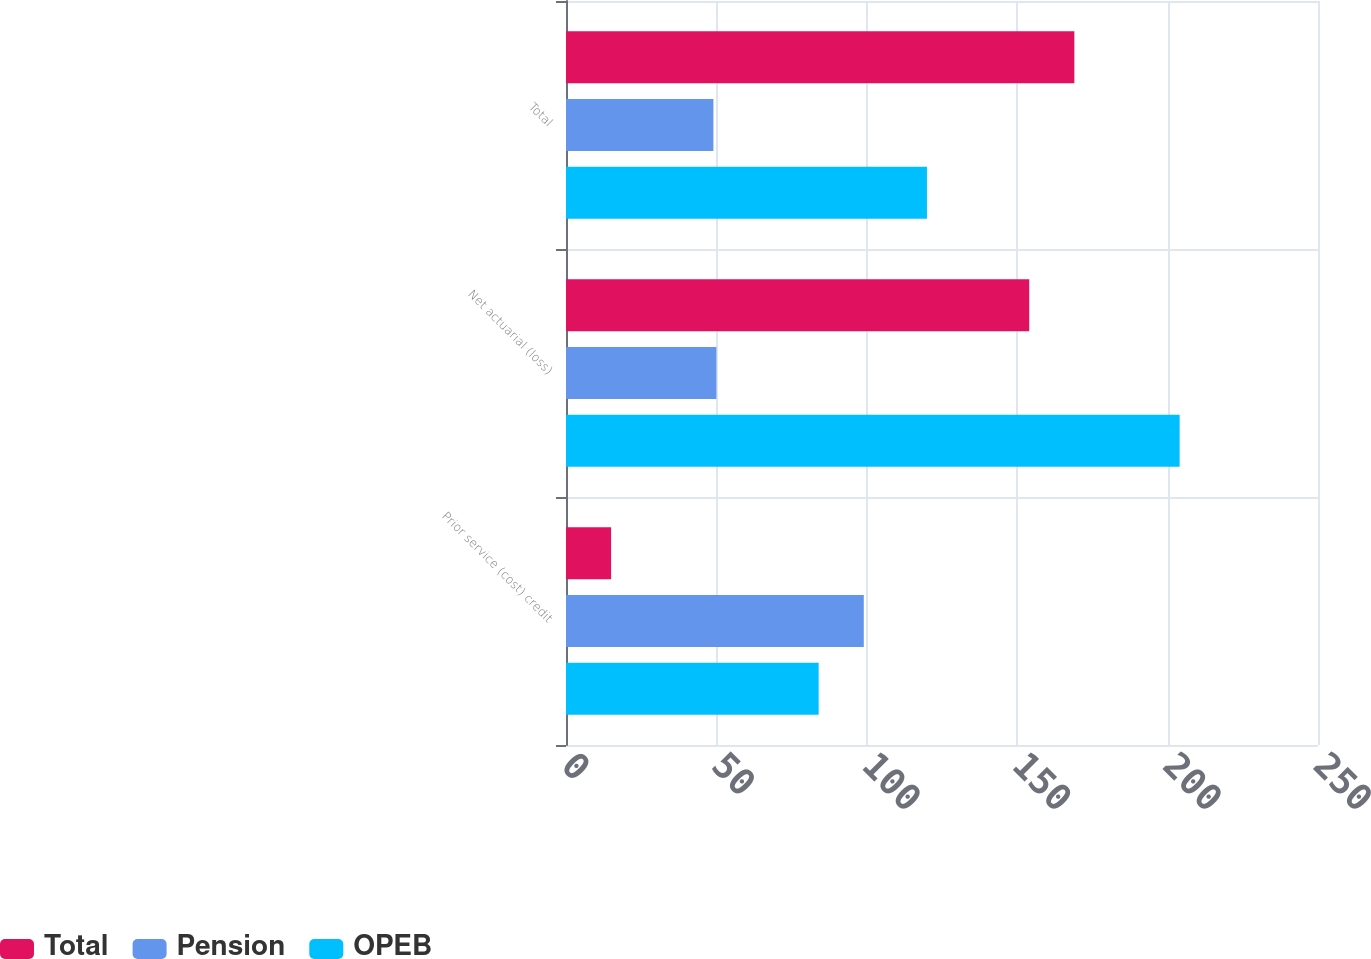Convert chart to OTSL. <chart><loc_0><loc_0><loc_500><loc_500><stacked_bar_chart><ecel><fcel>Prior service (cost) credit<fcel>Net actuarial (loss)<fcel>Total<nl><fcel>Total<fcel>15<fcel>154<fcel>169<nl><fcel>Pension<fcel>99<fcel>50<fcel>49<nl><fcel>OPEB<fcel>84<fcel>204<fcel>120<nl></chart> 